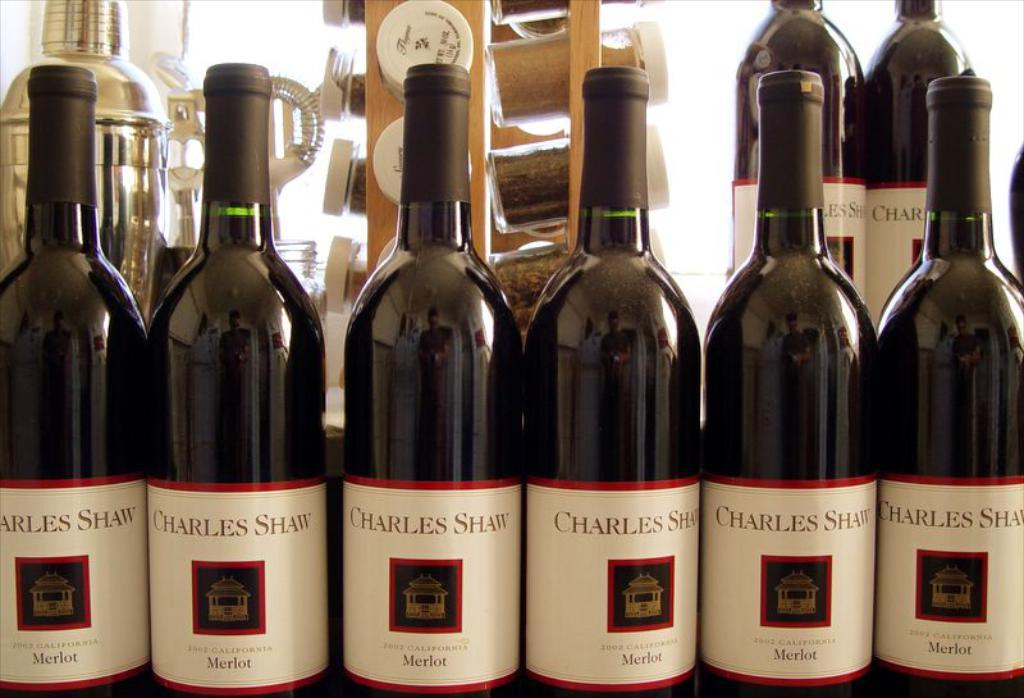Provide a one-sentence caption for the provided image. A row of wine bottles display the brand Charles Shaw. 